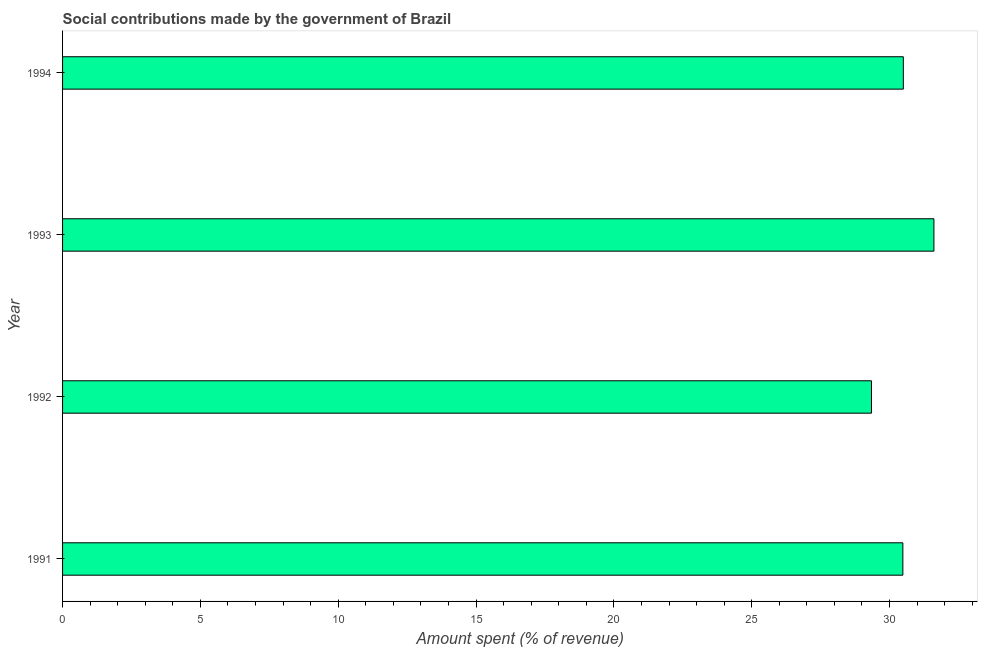What is the title of the graph?
Your response must be concise. Social contributions made by the government of Brazil. What is the label or title of the X-axis?
Keep it short and to the point. Amount spent (% of revenue). What is the label or title of the Y-axis?
Offer a very short reply. Year. What is the amount spent in making social contributions in 1992?
Ensure brevity in your answer.  29.34. Across all years, what is the maximum amount spent in making social contributions?
Offer a very short reply. 31.61. Across all years, what is the minimum amount spent in making social contributions?
Ensure brevity in your answer.  29.34. In which year was the amount spent in making social contributions maximum?
Offer a very short reply. 1993. In which year was the amount spent in making social contributions minimum?
Make the answer very short. 1992. What is the sum of the amount spent in making social contributions?
Keep it short and to the point. 121.94. What is the difference between the amount spent in making social contributions in 1991 and 1993?
Your answer should be very brief. -1.13. What is the average amount spent in making social contributions per year?
Make the answer very short. 30.48. What is the median amount spent in making social contributions?
Make the answer very short. 30.49. What is the ratio of the amount spent in making social contributions in 1991 to that in 1992?
Offer a terse response. 1.04. What is the difference between the highest and the second highest amount spent in making social contributions?
Your response must be concise. 1.11. What is the difference between the highest and the lowest amount spent in making social contributions?
Ensure brevity in your answer.  2.27. In how many years, is the amount spent in making social contributions greater than the average amount spent in making social contributions taken over all years?
Your answer should be very brief. 2. How many bars are there?
Provide a short and direct response. 4. How many years are there in the graph?
Keep it short and to the point. 4. What is the difference between two consecutive major ticks on the X-axis?
Provide a succinct answer. 5. Are the values on the major ticks of X-axis written in scientific E-notation?
Your response must be concise. No. What is the Amount spent (% of revenue) in 1991?
Provide a succinct answer. 30.48. What is the Amount spent (% of revenue) in 1992?
Provide a short and direct response. 29.34. What is the Amount spent (% of revenue) of 1993?
Your response must be concise. 31.61. What is the Amount spent (% of revenue) of 1994?
Your answer should be compact. 30.5. What is the difference between the Amount spent (% of revenue) in 1991 and 1992?
Keep it short and to the point. 1.14. What is the difference between the Amount spent (% of revenue) in 1991 and 1993?
Your answer should be very brief. -1.13. What is the difference between the Amount spent (% of revenue) in 1991 and 1994?
Ensure brevity in your answer.  -0.02. What is the difference between the Amount spent (% of revenue) in 1992 and 1993?
Provide a short and direct response. -2.27. What is the difference between the Amount spent (% of revenue) in 1992 and 1994?
Your answer should be very brief. -1.16. What is the difference between the Amount spent (% of revenue) in 1993 and 1994?
Provide a succinct answer. 1.11. What is the ratio of the Amount spent (% of revenue) in 1991 to that in 1992?
Make the answer very short. 1.04. What is the ratio of the Amount spent (% of revenue) in 1992 to that in 1993?
Your answer should be very brief. 0.93. What is the ratio of the Amount spent (% of revenue) in 1993 to that in 1994?
Your response must be concise. 1.04. 